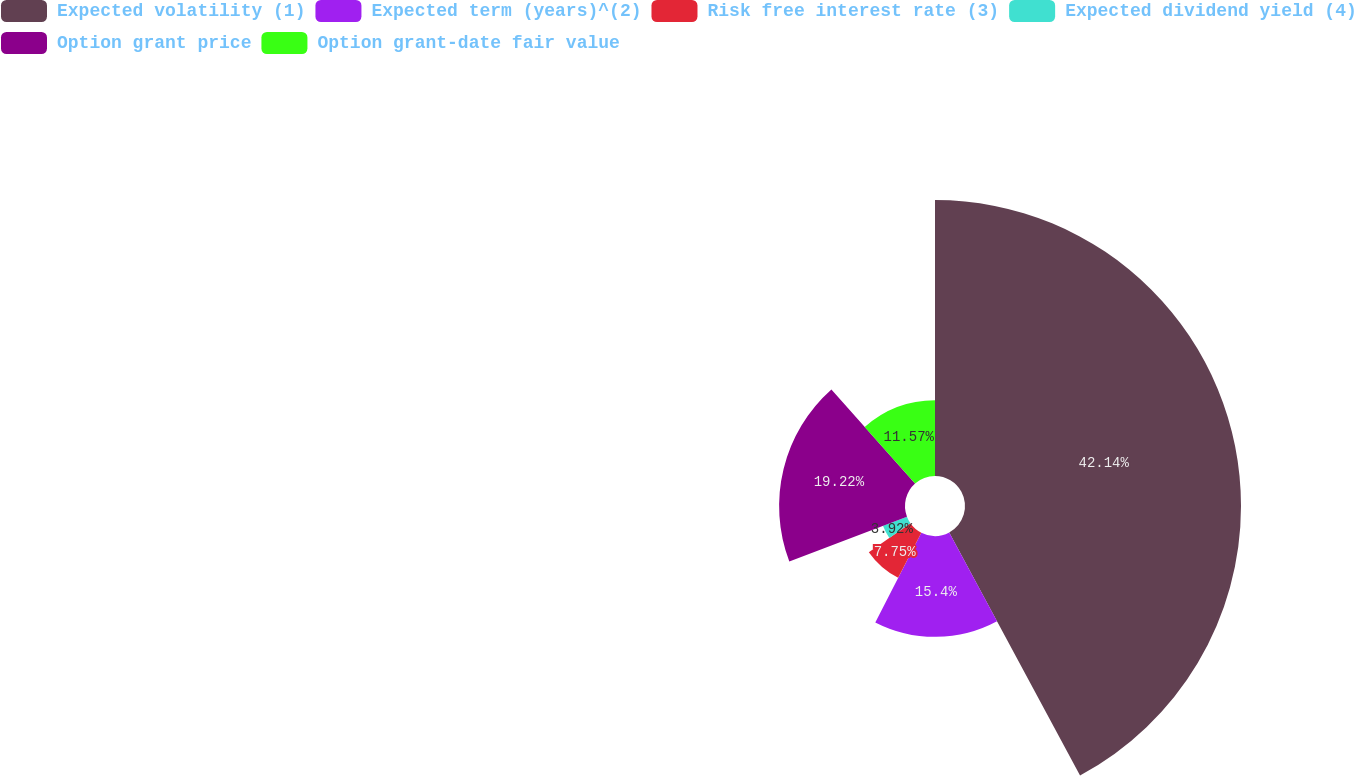Convert chart. <chart><loc_0><loc_0><loc_500><loc_500><pie_chart><fcel>Expected volatility (1)<fcel>Expected term (years)^(2)<fcel>Risk free interest rate (3)<fcel>Expected dividend yield (4)<fcel>Option grant price<fcel>Option grant-date fair value<nl><fcel>42.14%<fcel>15.4%<fcel>7.75%<fcel>3.92%<fcel>19.22%<fcel>11.57%<nl></chart> 